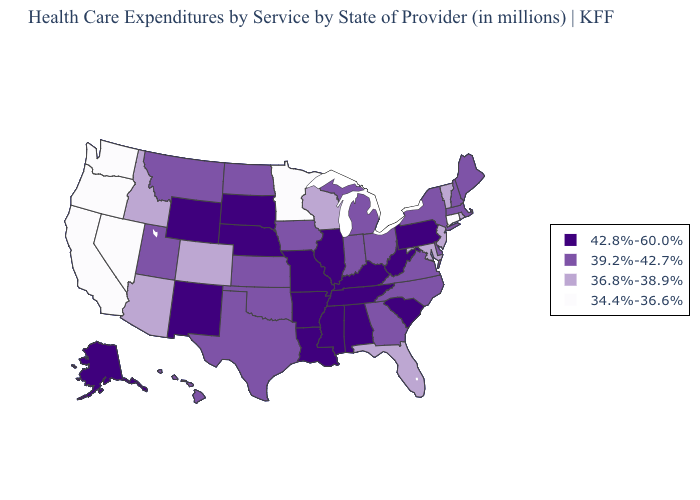Name the states that have a value in the range 42.8%-60.0%?
Concise answer only. Alabama, Alaska, Arkansas, Illinois, Kentucky, Louisiana, Mississippi, Missouri, Nebraska, New Mexico, Pennsylvania, South Carolina, South Dakota, Tennessee, West Virginia, Wyoming. Does the first symbol in the legend represent the smallest category?
Short answer required. No. Among the states that border Connecticut , which have the highest value?
Write a very short answer. Massachusetts, New York. Name the states that have a value in the range 39.2%-42.7%?
Write a very short answer. Delaware, Georgia, Hawaii, Indiana, Iowa, Kansas, Maine, Massachusetts, Michigan, Montana, New Hampshire, New York, North Carolina, North Dakota, Ohio, Oklahoma, Texas, Utah, Virginia. Name the states that have a value in the range 34.4%-36.6%?
Concise answer only. California, Connecticut, Minnesota, Nevada, Oregon, Washington. Name the states that have a value in the range 42.8%-60.0%?
Keep it brief. Alabama, Alaska, Arkansas, Illinois, Kentucky, Louisiana, Mississippi, Missouri, Nebraska, New Mexico, Pennsylvania, South Carolina, South Dakota, Tennessee, West Virginia, Wyoming. Among the states that border Montana , does Idaho have the lowest value?
Short answer required. Yes. Does Nebraska have a higher value than North Carolina?
Give a very brief answer. Yes. Does the map have missing data?
Write a very short answer. No. What is the value of Connecticut?
Be succinct. 34.4%-36.6%. What is the lowest value in states that border South Dakota?
Write a very short answer. 34.4%-36.6%. What is the lowest value in the USA?
Short answer required. 34.4%-36.6%. What is the value of Virginia?
Write a very short answer. 39.2%-42.7%. Does New Mexico have the highest value in the USA?
Concise answer only. Yes. What is the lowest value in the South?
Be succinct. 36.8%-38.9%. 